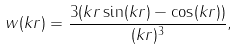<formula> <loc_0><loc_0><loc_500><loc_500>w ( k r ) = \frac { 3 ( k r \sin ( k r ) - \cos ( k r ) ) } { ( k r ) ^ { 3 } } ,</formula> 